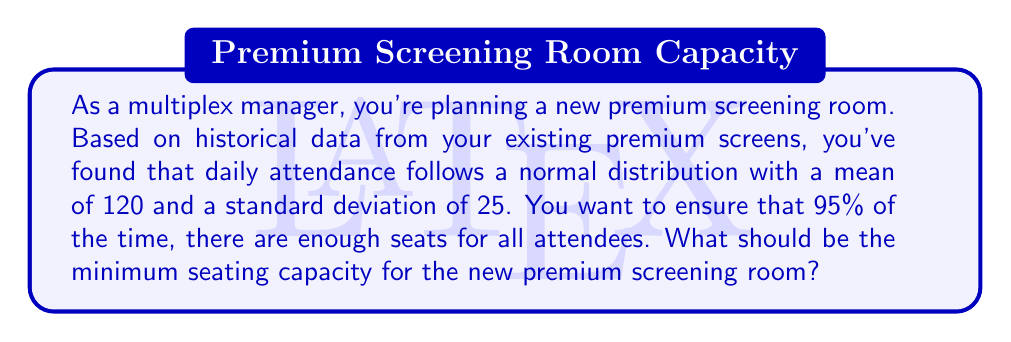Show me your answer to this math problem. To solve this problem, we need to use the properties of the normal distribution and the concept of z-scores.

1. We know that the daily attendance follows a normal distribution with:
   $\mu = 120$ (mean)
   $\sigma = 25$ (standard deviation)

2. We want to find the number of seats that will accommodate 95% of attendees. This means we're looking for the 95th percentile of the distribution.

3. In a normal distribution, 95% of the data falls within 1.645 standard deviations above the mean. This corresponds to a z-score of 1.645.

4. The formula to calculate the value X (number of seats) given a z-score is:
   $$X = \mu + (z \times \sigma)$$

5. Plugging in our values:
   $$X = 120 + (1.645 \times 25)$$

6. Calculating:
   $$X = 120 + 41.125 = 161.125$$

7. Since we can't have a fractional number of seats, we round up to the nearest whole number.
Answer: The minimum seating capacity for the new premium screening room should be 162 seats. 